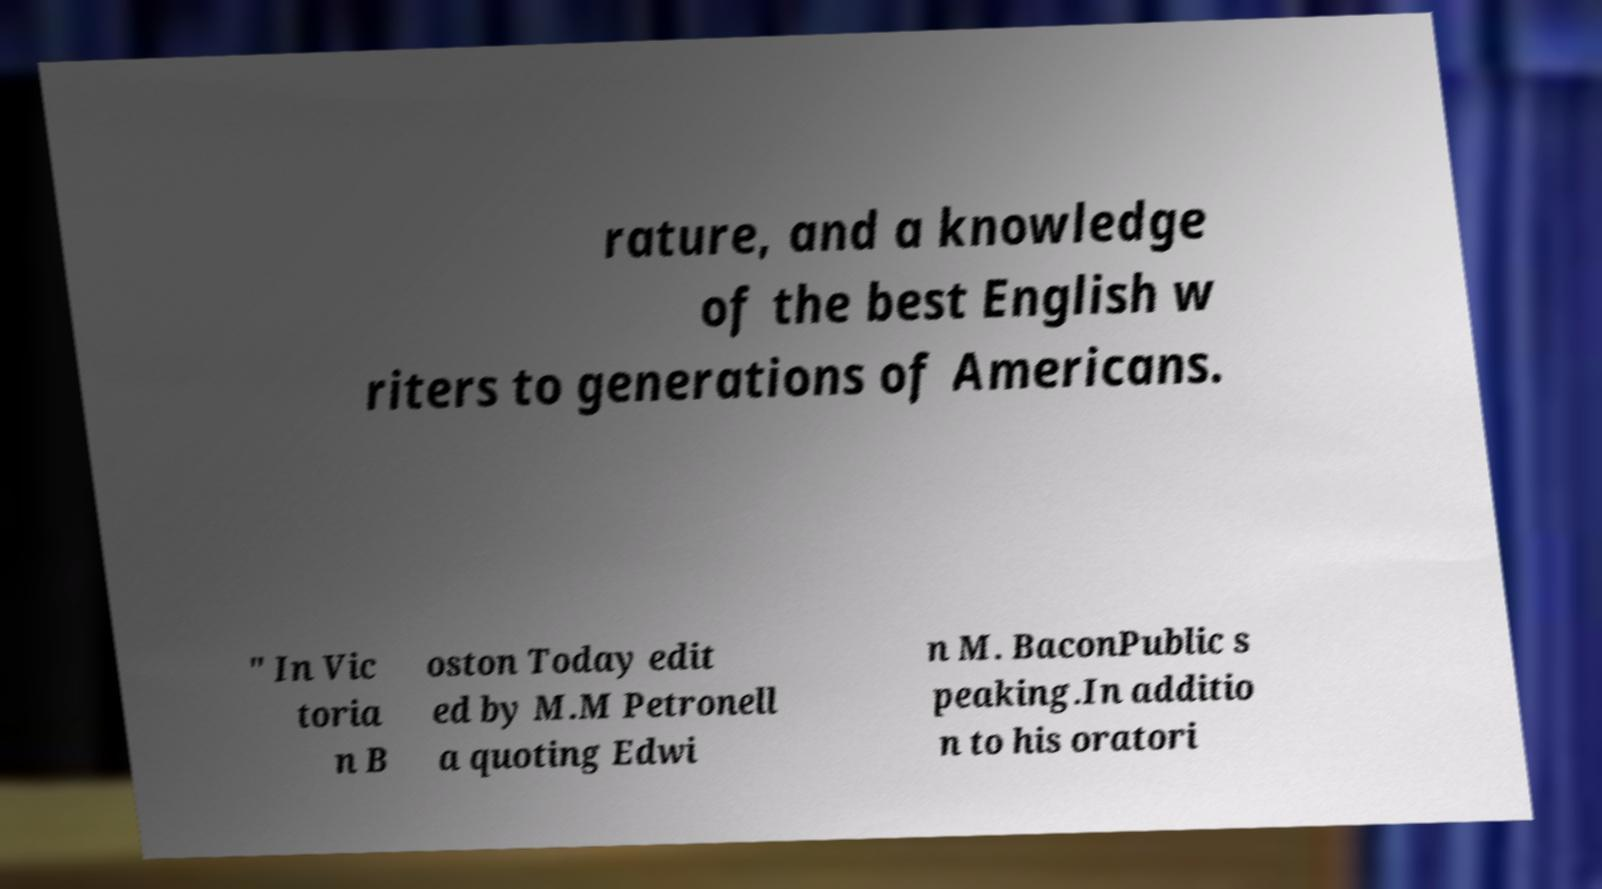Can you read and provide the text displayed in the image?This photo seems to have some interesting text. Can you extract and type it out for me? rature, and a knowledge of the best English w riters to generations of Americans. " In Vic toria n B oston Today edit ed by M.M Petronell a quoting Edwi n M. BaconPublic s peaking.In additio n to his oratori 